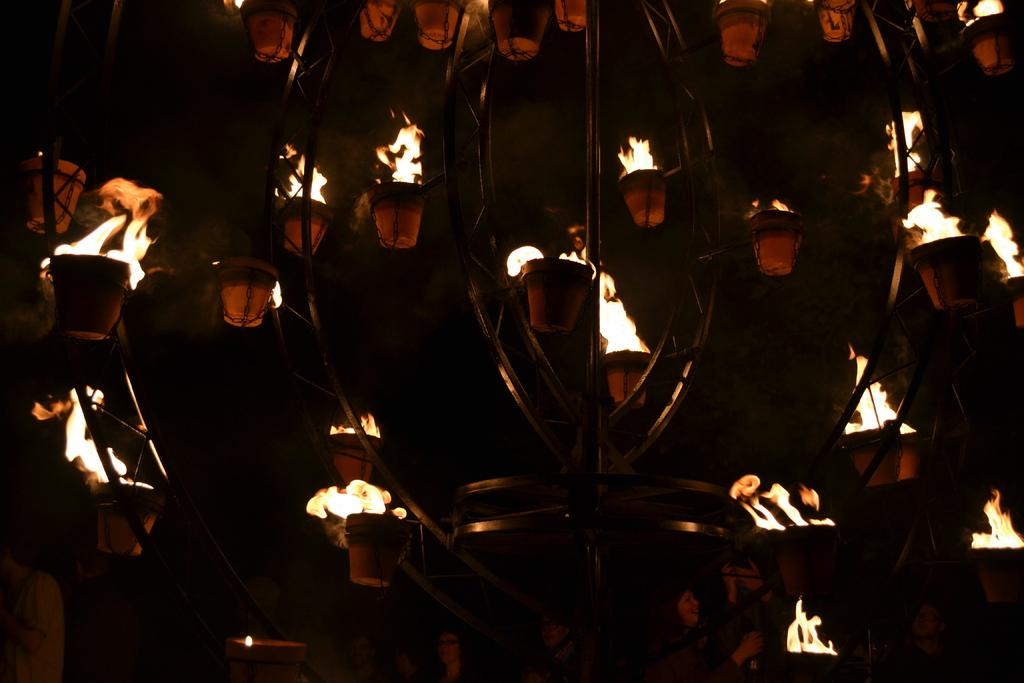What type of structure is present in the image? There is a metal stand in the image. What is the color of the metal stand? The metal stand is black in color. What is placed on the metal stand? There are pots on the stand. What is happening to the contents of the pots? There is fire in the pots. What can be seen in the background of the image? The sky is visible in the background of the image, and it appears dark. In which direction is the person driving in the image? There is no person driving in the image; it features a metal stand with pots and fire. 